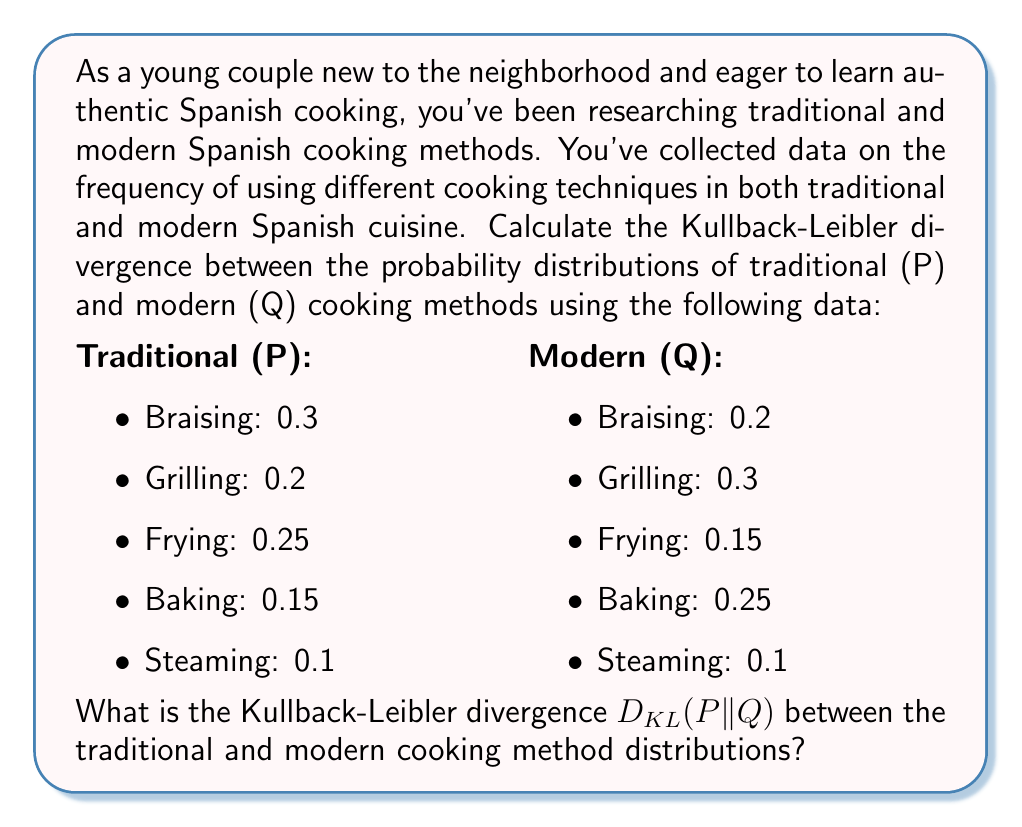Give your solution to this math problem. To calculate the Kullback-Leibler divergence between the probability distributions P (traditional) and Q (modern), we'll use the formula:

$$D_{KL}(P||Q) = \sum_{i} P(i) \log_2 \frac{P(i)}{Q(i)}$$

Where $P(i)$ and $Q(i)$ are the probabilities of each cooking method in the traditional and modern distributions, respectively.

Let's calculate each term of the sum:

1. Braising:
   $P(i) = 0.3$, $Q(i) = 0.2$
   $0.3 \log_2 \frac{0.3}{0.2} = 0.3 \log_2 1.5 = 0.3 \cdot 0.5850 = 0.1755$

2. Grilling:
   $P(i) = 0.2$, $Q(i) = 0.3$
   $0.2 \log_2 \frac{0.2}{0.3} = 0.2 \log_2 0.6667 = 0.2 \cdot (-0.5850) = -0.1170$

3. Frying:
   $P(i) = 0.25$, $Q(i) = 0.15$
   $0.25 \log_2 \frac{0.25}{0.15} = 0.25 \log_2 1.6667 = 0.25 \cdot 0.7370 = 0.1843$

4. Baking:
   $P(i) = 0.15$, $Q(i) = 0.25$
   $0.15 \log_2 \frac{0.15}{0.25} = 0.15 \log_2 0.6 = 0.15 \cdot (-0.7370) = -0.1106$

5. Steaming:
   $P(i) = 0.1$, $Q(i) = 0.1$
   $0.1 \log_2 \frac{0.1}{0.1} = 0.1 \log_2 1 = 0$

Now, we sum all these terms:

$$D_{KL}(P||Q) = 0.1755 + (-0.1170) + 0.1843 + (-0.1106) + 0 = 0.1322$$

Therefore, the Kullback-Leibler divergence between the traditional and modern cooking method distributions is approximately 0.1322 bits.
Answer: $D_{KL}(P||Q) \approx 0.1322$ bits 